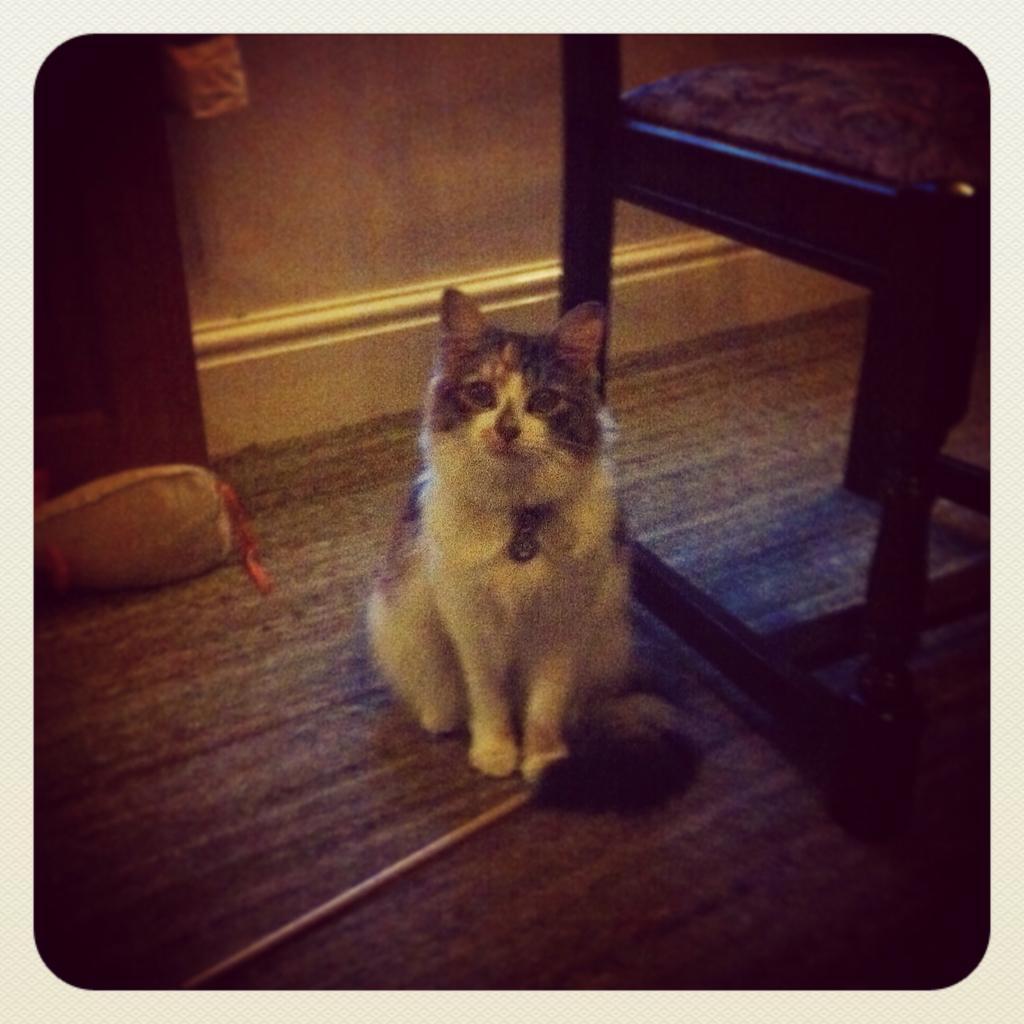Please provide a concise description of this image. In this image I see a cat over here which is of white and black in color and I see a chair over here and I see a thing over here and I see the floor. In the background I see the wall. 